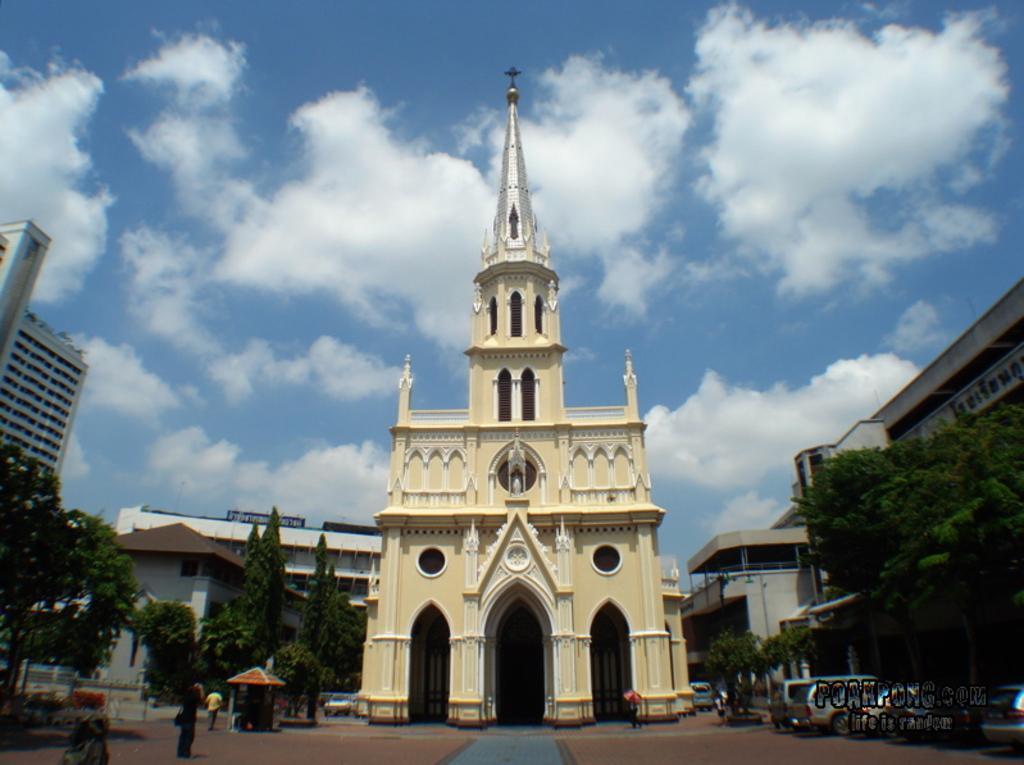Can you describe this image briefly? In this picture there is a church in the center of the image and there are buildings and trees on the right and left side of the image, there are cars and people at the bottom side of the image. 